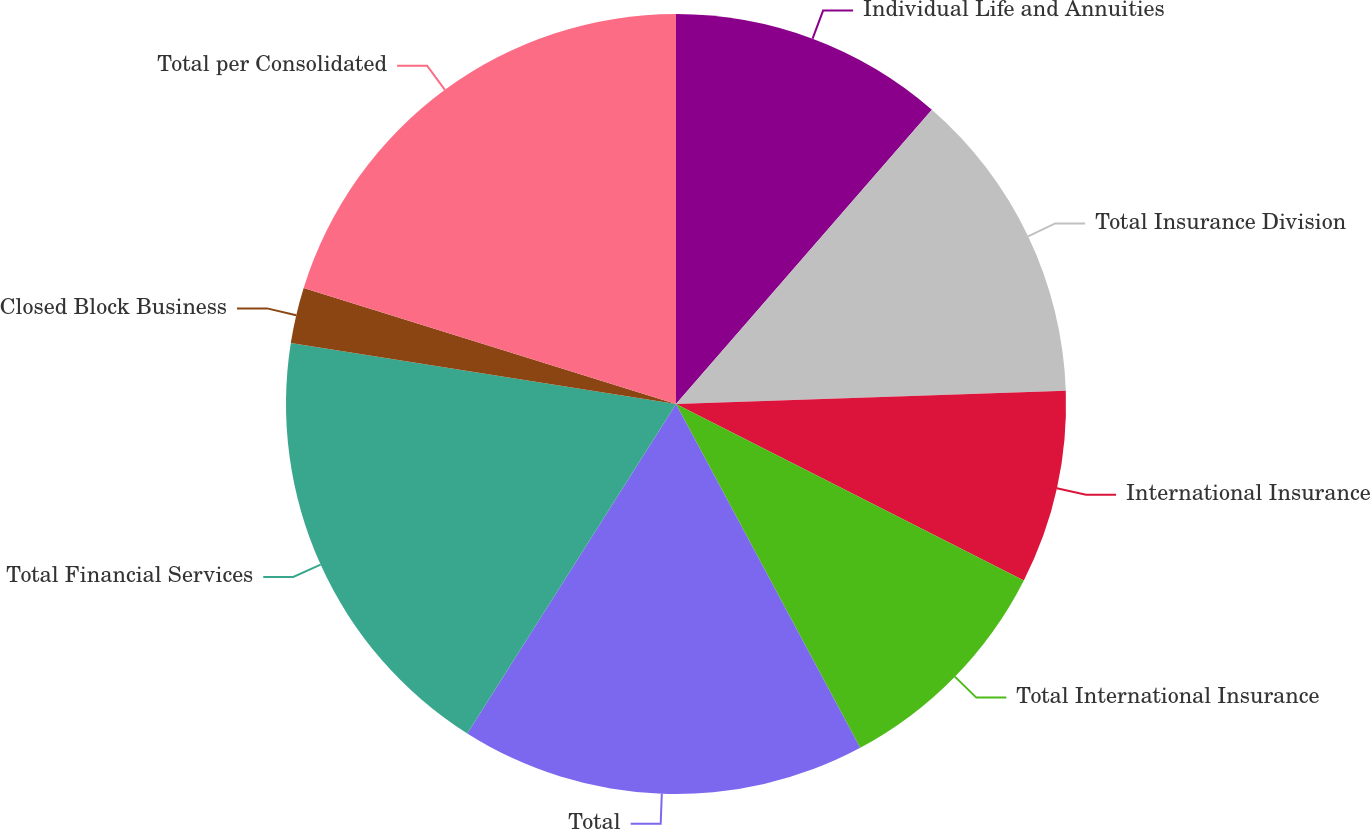Convert chart to OTSL. <chart><loc_0><loc_0><loc_500><loc_500><pie_chart><fcel>Individual Life and Annuities<fcel>Total Insurance Division<fcel>International Insurance<fcel>Total International Insurance<fcel>Total<fcel>Total Financial Services<fcel>Closed Block Business<fcel>Total per Consolidated<nl><fcel>11.39%<fcel>13.07%<fcel>8.01%<fcel>9.7%<fcel>16.82%<fcel>18.51%<fcel>2.31%<fcel>20.19%<nl></chart> 